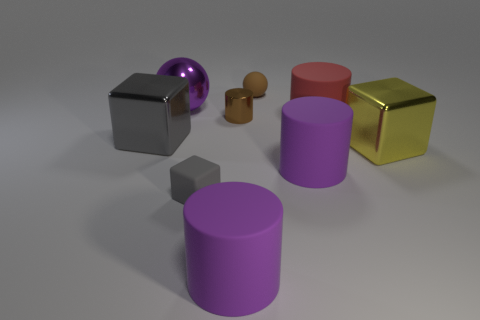Subtract all brown metallic cylinders. How many cylinders are left? 3 Subtract all purple cylinders. How many cylinders are left? 2 Add 5 purple things. How many purple things exist? 8 Add 1 big green matte objects. How many objects exist? 10 Subtract 0 cyan cylinders. How many objects are left? 9 Subtract all cylinders. How many objects are left? 5 Subtract 2 cylinders. How many cylinders are left? 2 Subtract all brown spheres. Subtract all cyan cylinders. How many spheres are left? 1 Subtract all red cubes. How many yellow balls are left? 0 Subtract all cyan matte balls. Subtract all brown rubber things. How many objects are left? 8 